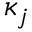Convert formula to latex. <formula><loc_0><loc_0><loc_500><loc_500>\kappa _ { j }</formula> 